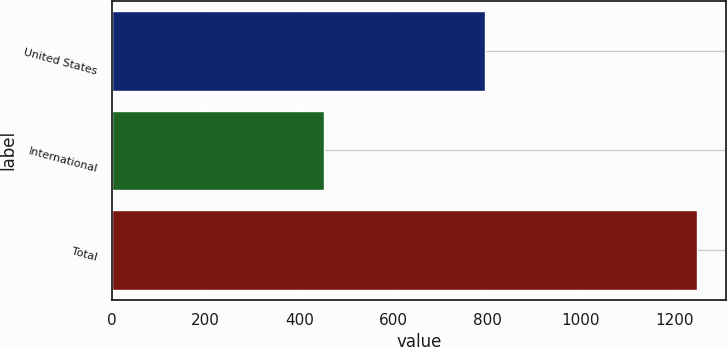Convert chart. <chart><loc_0><loc_0><loc_500><loc_500><bar_chart><fcel>United States<fcel>International<fcel>Total<nl><fcel>795.3<fcel>451.3<fcel>1246.6<nl></chart> 